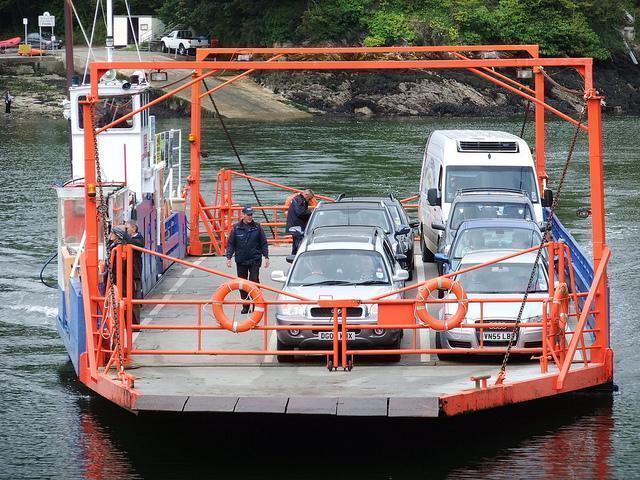Why are the vehicles on the boat?
Pick the correct solution from the four options below to address the question.
Options: Cross water, for sale, cleaning them, free ride. Cross water. 